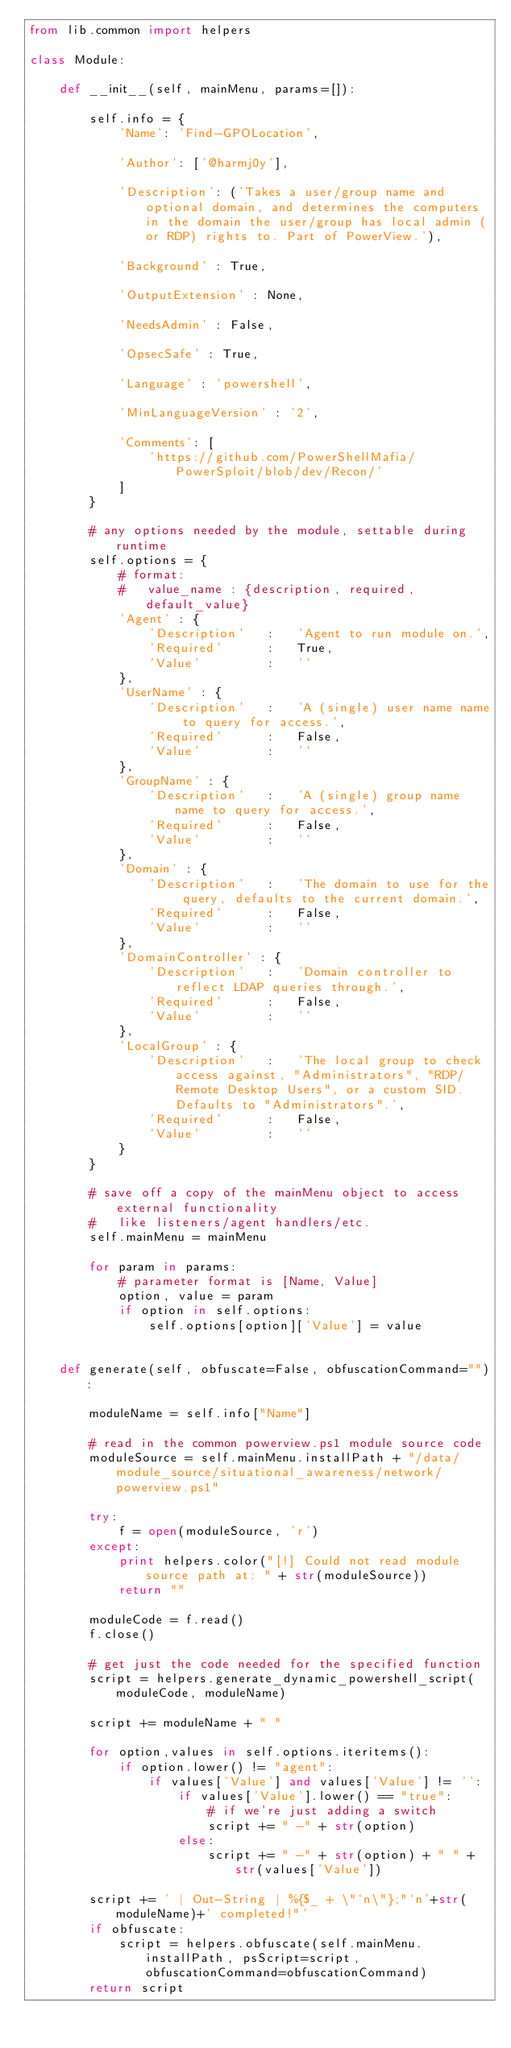<code> <loc_0><loc_0><loc_500><loc_500><_Python_>from lib.common import helpers

class Module:

    def __init__(self, mainMenu, params=[]):

        self.info = {
            'Name': 'Find-GPOLocation',

            'Author': ['@harmj0y'],

            'Description': ('Takes a user/group name and optional domain, and determines the computers in the domain the user/group has local admin (or RDP) rights to. Part of PowerView.'),

            'Background' : True,

            'OutputExtension' : None,
            
            'NeedsAdmin' : False,

            'OpsecSafe' : True,
            
            'Language' : 'powershell',

            'MinLanguageVersion' : '2',
            
            'Comments': [
                'https://github.com/PowerShellMafia/PowerSploit/blob/dev/Recon/'
            ]
        }

        # any options needed by the module, settable during runtime
        self.options = {
            # format:
            #   value_name : {description, required, default_value}
            'Agent' : {
                'Description'   :   'Agent to run module on.',
                'Required'      :   True,
                'Value'         :   ''
            },
            'UserName' : {
                'Description'   :   'A (single) user name name to query for access.',
                'Required'      :   False,
                'Value'         :   ''
            },
            'GroupName' : {
                'Description'   :   'A (single) group name name to query for access.',
                'Required'      :   False,
                'Value'         :   ''
            },
            'Domain' : {
                'Description'   :   'The domain to use for the query, defaults to the current domain.',
                'Required'      :   False,
                'Value'         :   ''
            },
            'DomainController' : {
                'Description'   :   'Domain controller to reflect LDAP queries through.',
                'Required'      :   False,
                'Value'         :   ''
            },
            'LocalGroup' : {
                'Description'   :   'The local group to check access against, "Administrators", "RDP/Remote Desktop Users", or a custom SID. Defaults to "Administrators".',
                'Required'      :   False,
                'Value'         :   ''
            }
        }

        # save off a copy of the mainMenu object to access external functionality
        #   like listeners/agent handlers/etc.
        self.mainMenu = mainMenu

        for param in params:
            # parameter format is [Name, Value]
            option, value = param
            if option in self.options:
                self.options[option]['Value'] = value


    def generate(self, obfuscate=False, obfuscationCommand=""):
        
        moduleName = self.info["Name"]
        
        # read in the common powerview.ps1 module source code
        moduleSource = self.mainMenu.installPath + "/data/module_source/situational_awareness/network/powerview.ps1"

        try:
            f = open(moduleSource, 'r')
        except:
            print helpers.color("[!] Could not read module source path at: " + str(moduleSource))
            return ""

        moduleCode = f.read()
        f.close()

        # get just the code needed for the specified function
        script = helpers.generate_dynamic_powershell_script(moduleCode, moduleName)

        script += moduleName + " "

        for option,values in self.options.iteritems():
            if option.lower() != "agent":
                if values['Value'] and values['Value'] != '':
                    if values['Value'].lower() == "true":
                        # if we're just adding a switch
                        script += " -" + str(option)
                    else:
                        script += " -" + str(option) + " " + str(values['Value']) 

        script += ' | Out-String | %{$_ + \"`n\"};"`n'+str(moduleName)+' completed!"'
        if obfuscate:
            script = helpers.obfuscate(self.mainMenu.installPath, psScript=script, obfuscationCommand=obfuscationCommand)
        return script
</code> 